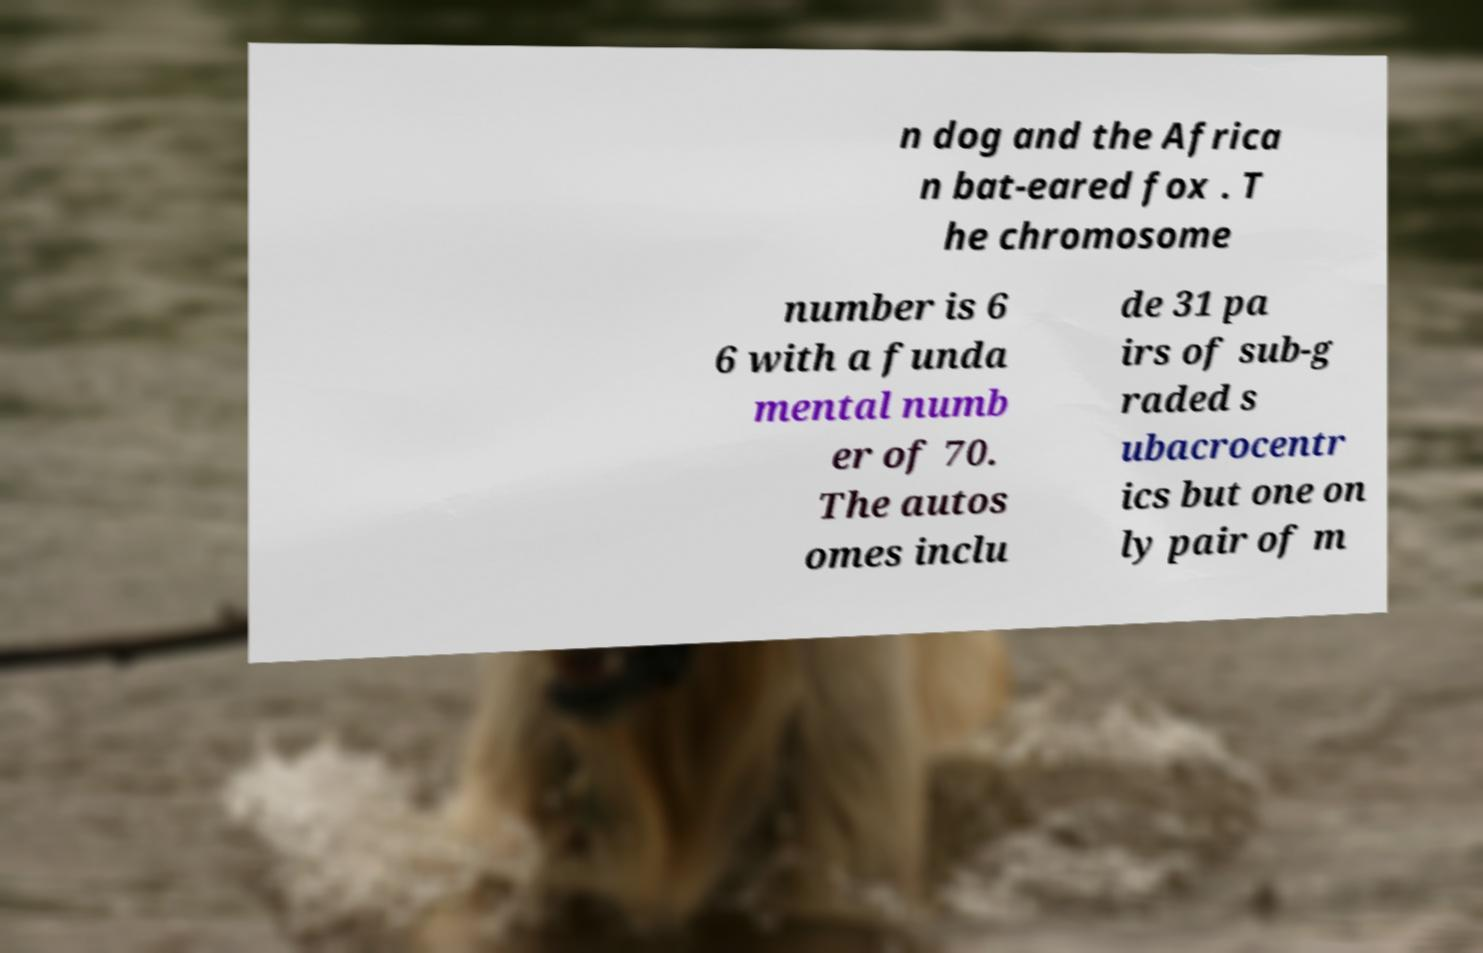Could you assist in decoding the text presented in this image and type it out clearly? n dog and the Africa n bat-eared fox . T he chromosome number is 6 6 with a funda mental numb er of 70. The autos omes inclu de 31 pa irs of sub-g raded s ubacrocentr ics but one on ly pair of m 